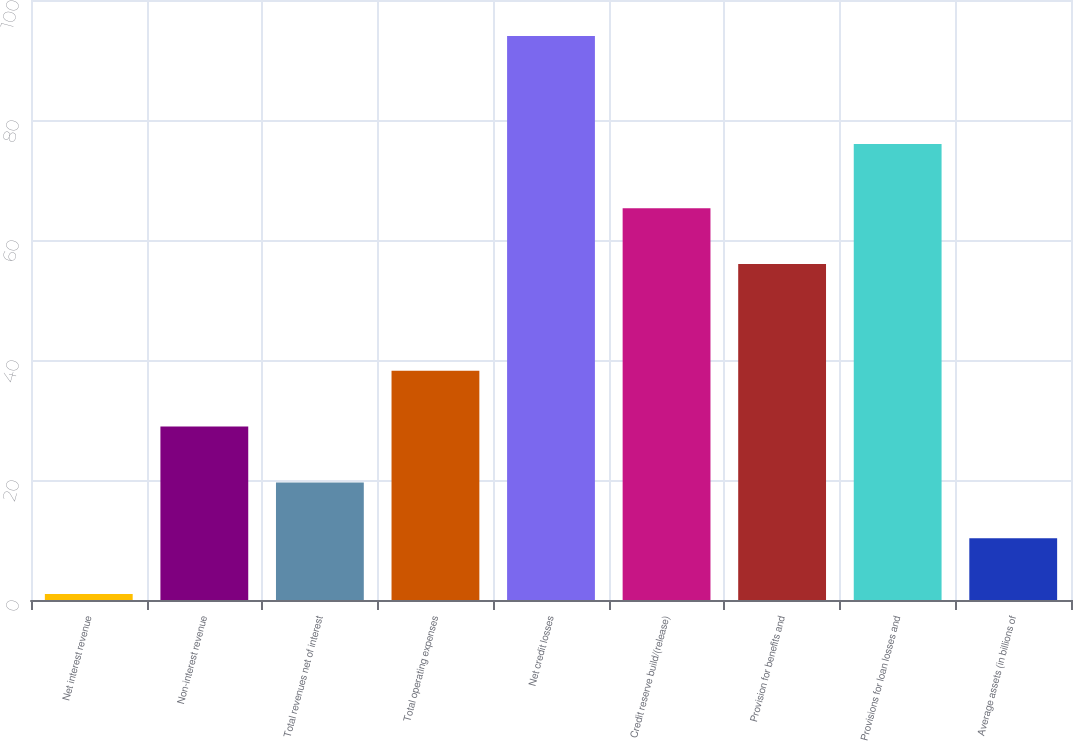<chart> <loc_0><loc_0><loc_500><loc_500><bar_chart><fcel>Net interest revenue<fcel>Non-interest revenue<fcel>Total revenues net of interest<fcel>Total operating expenses<fcel>Net credit losses<fcel>Credit reserve build/(release)<fcel>Provision for benefits and<fcel>Provisions for loan losses and<fcel>Average assets (in billions of<nl><fcel>1<fcel>28.9<fcel>19.6<fcel>38.2<fcel>94<fcel>65.3<fcel>56<fcel>76<fcel>10.3<nl></chart> 